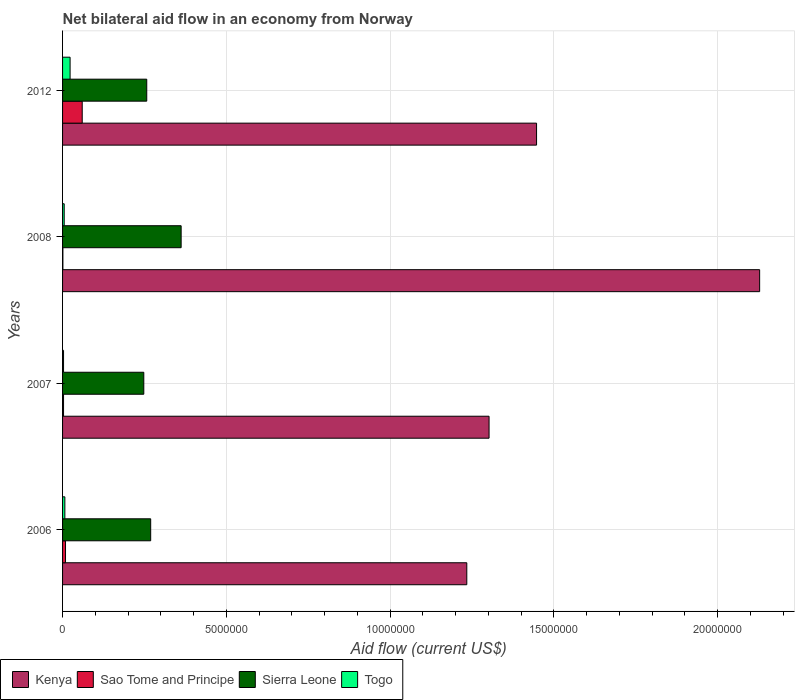How many different coloured bars are there?
Your response must be concise. 4. Are the number of bars on each tick of the Y-axis equal?
Your response must be concise. Yes. How many bars are there on the 2nd tick from the bottom?
Offer a terse response. 4. In how many cases, is the number of bars for a given year not equal to the number of legend labels?
Give a very brief answer. 0. What is the net bilateral aid flow in Sierra Leone in 2012?
Make the answer very short. 2.57e+06. Across all years, what is the minimum net bilateral aid flow in Kenya?
Your answer should be compact. 1.23e+07. In which year was the net bilateral aid flow in Sao Tome and Principe maximum?
Provide a short and direct response. 2012. In which year was the net bilateral aid flow in Sierra Leone minimum?
Your answer should be very brief. 2007. What is the total net bilateral aid flow in Kenya in the graph?
Ensure brevity in your answer.  6.11e+07. What is the difference between the net bilateral aid flow in Sao Tome and Principe in 2007 and the net bilateral aid flow in Kenya in 2012?
Your response must be concise. -1.44e+07. What is the average net bilateral aid flow in Sierra Leone per year?
Give a very brief answer. 2.84e+06. In the year 2007, what is the difference between the net bilateral aid flow in Sierra Leone and net bilateral aid flow in Togo?
Your answer should be very brief. 2.45e+06. What is the ratio of the net bilateral aid flow in Sierra Leone in 2006 to that in 2012?
Your response must be concise. 1.05. Is the net bilateral aid flow in Sierra Leone in 2008 less than that in 2012?
Make the answer very short. No. Is the difference between the net bilateral aid flow in Sierra Leone in 2006 and 2012 greater than the difference between the net bilateral aid flow in Togo in 2006 and 2012?
Your answer should be very brief. Yes. What is the difference between the highest and the second highest net bilateral aid flow in Togo?
Your answer should be very brief. 1.60e+05. What is the difference between the highest and the lowest net bilateral aid flow in Sao Tome and Principe?
Your answer should be compact. 5.90e+05. In how many years, is the net bilateral aid flow in Togo greater than the average net bilateral aid flow in Togo taken over all years?
Provide a succinct answer. 1. Is it the case that in every year, the sum of the net bilateral aid flow in Kenya and net bilateral aid flow in Togo is greater than the sum of net bilateral aid flow in Sao Tome and Principe and net bilateral aid flow in Sierra Leone?
Provide a succinct answer. Yes. What does the 3rd bar from the top in 2007 represents?
Your answer should be very brief. Sao Tome and Principe. What does the 2nd bar from the bottom in 2007 represents?
Your answer should be compact. Sao Tome and Principe. Is it the case that in every year, the sum of the net bilateral aid flow in Sao Tome and Principe and net bilateral aid flow in Kenya is greater than the net bilateral aid flow in Togo?
Offer a very short reply. Yes. How many bars are there?
Provide a succinct answer. 16. Are all the bars in the graph horizontal?
Ensure brevity in your answer.  Yes. How many years are there in the graph?
Offer a terse response. 4. What is the difference between two consecutive major ticks on the X-axis?
Offer a very short reply. 5.00e+06. Does the graph contain grids?
Your response must be concise. Yes. Where does the legend appear in the graph?
Provide a succinct answer. Bottom left. How many legend labels are there?
Ensure brevity in your answer.  4. What is the title of the graph?
Offer a very short reply. Net bilateral aid flow in an economy from Norway. What is the Aid flow (current US$) of Kenya in 2006?
Your response must be concise. 1.23e+07. What is the Aid flow (current US$) of Sao Tome and Principe in 2006?
Your response must be concise. 9.00e+04. What is the Aid flow (current US$) in Sierra Leone in 2006?
Your response must be concise. 2.69e+06. What is the Aid flow (current US$) in Kenya in 2007?
Make the answer very short. 1.30e+07. What is the Aid flow (current US$) in Sao Tome and Principe in 2007?
Provide a succinct answer. 3.00e+04. What is the Aid flow (current US$) in Sierra Leone in 2007?
Make the answer very short. 2.48e+06. What is the Aid flow (current US$) in Kenya in 2008?
Ensure brevity in your answer.  2.13e+07. What is the Aid flow (current US$) of Sao Tome and Principe in 2008?
Give a very brief answer. 10000. What is the Aid flow (current US$) of Sierra Leone in 2008?
Keep it short and to the point. 3.62e+06. What is the Aid flow (current US$) in Togo in 2008?
Offer a terse response. 5.00e+04. What is the Aid flow (current US$) in Kenya in 2012?
Your response must be concise. 1.45e+07. What is the Aid flow (current US$) in Sierra Leone in 2012?
Give a very brief answer. 2.57e+06. What is the Aid flow (current US$) in Togo in 2012?
Your answer should be compact. 2.30e+05. Across all years, what is the maximum Aid flow (current US$) of Kenya?
Give a very brief answer. 2.13e+07. Across all years, what is the maximum Aid flow (current US$) of Sao Tome and Principe?
Provide a short and direct response. 6.00e+05. Across all years, what is the maximum Aid flow (current US$) in Sierra Leone?
Make the answer very short. 3.62e+06. Across all years, what is the minimum Aid flow (current US$) in Kenya?
Provide a short and direct response. 1.23e+07. Across all years, what is the minimum Aid flow (current US$) of Sao Tome and Principe?
Your response must be concise. 10000. Across all years, what is the minimum Aid flow (current US$) of Sierra Leone?
Make the answer very short. 2.48e+06. What is the total Aid flow (current US$) in Kenya in the graph?
Provide a short and direct response. 6.11e+07. What is the total Aid flow (current US$) of Sao Tome and Principe in the graph?
Keep it short and to the point. 7.30e+05. What is the total Aid flow (current US$) in Sierra Leone in the graph?
Make the answer very short. 1.14e+07. What is the total Aid flow (current US$) in Togo in the graph?
Keep it short and to the point. 3.80e+05. What is the difference between the Aid flow (current US$) of Kenya in 2006 and that in 2007?
Offer a very short reply. -6.80e+05. What is the difference between the Aid flow (current US$) of Sierra Leone in 2006 and that in 2007?
Your answer should be very brief. 2.10e+05. What is the difference between the Aid flow (current US$) of Togo in 2006 and that in 2007?
Provide a succinct answer. 4.00e+04. What is the difference between the Aid flow (current US$) in Kenya in 2006 and that in 2008?
Your answer should be compact. -8.94e+06. What is the difference between the Aid flow (current US$) in Sao Tome and Principe in 2006 and that in 2008?
Give a very brief answer. 8.00e+04. What is the difference between the Aid flow (current US$) of Sierra Leone in 2006 and that in 2008?
Make the answer very short. -9.30e+05. What is the difference between the Aid flow (current US$) of Kenya in 2006 and that in 2012?
Your answer should be very brief. -2.13e+06. What is the difference between the Aid flow (current US$) in Sao Tome and Principe in 2006 and that in 2012?
Give a very brief answer. -5.10e+05. What is the difference between the Aid flow (current US$) of Togo in 2006 and that in 2012?
Your answer should be very brief. -1.60e+05. What is the difference between the Aid flow (current US$) in Kenya in 2007 and that in 2008?
Ensure brevity in your answer.  -8.26e+06. What is the difference between the Aid flow (current US$) of Sierra Leone in 2007 and that in 2008?
Your answer should be very brief. -1.14e+06. What is the difference between the Aid flow (current US$) of Kenya in 2007 and that in 2012?
Ensure brevity in your answer.  -1.45e+06. What is the difference between the Aid flow (current US$) in Sao Tome and Principe in 2007 and that in 2012?
Provide a short and direct response. -5.70e+05. What is the difference between the Aid flow (current US$) in Sierra Leone in 2007 and that in 2012?
Offer a terse response. -9.00e+04. What is the difference between the Aid flow (current US$) of Kenya in 2008 and that in 2012?
Ensure brevity in your answer.  6.81e+06. What is the difference between the Aid flow (current US$) of Sao Tome and Principe in 2008 and that in 2012?
Your response must be concise. -5.90e+05. What is the difference between the Aid flow (current US$) of Sierra Leone in 2008 and that in 2012?
Give a very brief answer. 1.05e+06. What is the difference between the Aid flow (current US$) in Kenya in 2006 and the Aid flow (current US$) in Sao Tome and Principe in 2007?
Your response must be concise. 1.23e+07. What is the difference between the Aid flow (current US$) of Kenya in 2006 and the Aid flow (current US$) of Sierra Leone in 2007?
Give a very brief answer. 9.86e+06. What is the difference between the Aid flow (current US$) in Kenya in 2006 and the Aid flow (current US$) in Togo in 2007?
Your answer should be very brief. 1.23e+07. What is the difference between the Aid flow (current US$) of Sao Tome and Principe in 2006 and the Aid flow (current US$) of Sierra Leone in 2007?
Give a very brief answer. -2.39e+06. What is the difference between the Aid flow (current US$) in Sao Tome and Principe in 2006 and the Aid flow (current US$) in Togo in 2007?
Provide a short and direct response. 6.00e+04. What is the difference between the Aid flow (current US$) of Sierra Leone in 2006 and the Aid flow (current US$) of Togo in 2007?
Keep it short and to the point. 2.66e+06. What is the difference between the Aid flow (current US$) of Kenya in 2006 and the Aid flow (current US$) of Sao Tome and Principe in 2008?
Provide a succinct answer. 1.23e+07. What is the difference between the Aid flow (current US$) in Kenya in 2006 and the Aid flow (current US$) in Sierra Leone in 2008?
Keep it short and to the point. 8.72e+06. What is the difference between the Aid flow (current US$) of Kenya in 2006 and the Aid flow (current US$) of Togo in 2008?
Offer a very short reply. 1.23e+07. What is the difference between the Aid flow (current US$) in Sao Tome and Principe in 2006 and the Aid flow (current US$) in Sierra Leone in 2008?
Offer a terse response. -3.53e+06. What is the difference between the Aid flow (current US$) of Sao Tome and Principe in 2006 and the Aid flow (current US$) of Togo in 2008?
Offer a very short reply. 4.00e+04. What is the difference between the Aid flow (current US$) of Sierra Leone in 2006 and the Aid flow (current US$) of Togo in 2008?
Your response must be concise. 2.64e+06. What is the difference between the Aid flow (current US$) of Kenya in 2006 and the Aid flow (current US$) of Sao Tome and Principe in 2012?
Offer a very short reply. 1.17e+07. What is the difference between the Aid flow (current US$) of Kenya in 2006 and the Aid flow (current US$) of Sierra Leone in 2012?
Offer a very short reply. 9.77e+06. What is the difference between the Aid flow (current US$) in Kenya in 2006 and the Aid flow (current US$) in Togo in 2012?
Your answer should be very brief. 1.21e+07. What is the difference between the Aid flow (current US$) in Sao Tome and Principe in 2006 and the Aid flow (current US$) in Sierra Leone in 2012?
Your answer should be very brief. -2.48e+06. What is the difference between the Aid flow (current US$) in Sierra Leone in 2006 and the Aid flow (current US$) in Togo in 2012?
Your response must be concise. 2.46e+06. What is the difference between the Aid flow (current US$) of Kenya in 2007 and the Aid flow (current US$) of Sao Tome and Principe in 2008?
Offer a very short reply. 1.30e+07. What is the difference between the Aid flow (current US$) in Kenya in 2007 and the Aid flow (current US$) in Sierra Leone in 2008?
Offer a very short reply. 9.40e+06. What is the difference between the Aid flow (current US$) of Kenya in 2007 and the Aid flow (current US$) of Togo in 2008?
Keep it short and to the point. 1.30e+07. What is the difference between the Aid flow (current US$) of Sao Tome and Principe in 2007 and the Aid flow (current US$) of Sierra Leone in 2008?
Make the answer very short. -3.59e+06. What is the difference between the Aid flow (current US$) of Sierra Leone in 2007 and the Aid flow (current US$) of Togo in 2008?
Ensure brevity in your answer.  2.43e+06. What is the difference between the Aid flow (current US$) of Kenya in 2007 and the Aid flow (current US$) of Sao Tome and Principe in 2012?
Provide a short and direct response. 1.24e+07. What is the difference between the Aid flow (current US$) of Kenya in 2007 and the Aid flow (current US$) of Sierra Leone in 2012?
Offer a very short reply. 1.04e+07. What is the difference between the Aid flow (current US$) of Kenya in 2007 and the Aid flow (current US$) of Togo in 2012?
Your response must be concise. 1.28e+07. What is the difference between the Aid flow (current US$) of Sao Tome and Principe in 2007 and the Aid flow (current US$) of Sierra Leone in 2012?
Make the answer very short. -2.54e+06. What is the difference between the Aid flow (current US$) of Sao Tome and Principe in 2007 and the Aid flow (current US$) of Togo in 2012?
Keep it short and to the point. -2.00e+05. What is the difference between the Aid flow (current US$) in Sierra Leone in 2007 and the Aid flow (current US$) in Togo in 2012?
Provide a succinct answer. 2.25e+06. What is the difference between the Aid flow (current US$) of Kenya in 2008 and the Aid flow (current US$) of Sao Tome and Principe in 2012?
Your answer should be compact. 2.07e+07. What is the difference between the Aid flow (current US$) of Kenya in 2008 and the Aid flow (current US$) of Sierra Leone in 2012?
Your answer should be very brief. 1.87e+07. What is the difference between the Aid flow (current US$) in Kenya in 2008 and the Aid flow (current US$) in Togo in 2012?
Ensure brevity in your answer.  2.10e+07. What is the difference between the Aid flow (current US$) in Sao Tome and Principe in 2008 and the Aid flow (current US$) in Sierra Leone in 2012?
Keep it short and to the point. -2.56e+06. What is the difference between the Aid flow (current US$) in Sao Tome and Principe in 2008 and the Aid flow (current US$) in Togo in 2012?
Your answer should be compact. -2.20e+05. What is the difference between the Aid flow (current US$) of Sierra Leone in 2008 and the Aid flow (current US$) of Togo in 2012?
Make the answer very short. 3.39e+06. What is the average Aid flow (current US$) in Kenya per year?
Offer a very short reply. 1.53e+07. What is the average Aid flow (current US$) of Sao Tome and Principe per year?
Provide a succinct answer. 1.82e+05. What is the average Aid flow (current US$) in Sierra Leone per year?
Ensure brevity in your answer.  2.84e+06. What is the average Aid flow (current US$) of Togo per year?
Give a very brief answer. 9.50e+04. In the year 2006, what is the difference between the Aid flow (current US$) of Kenya and Aid flow (current US$) of Sao Tome and Principe?
Give a very brief answer. 1.22e+07. In the year 2006, what is the difference between the Aid flow (current US$) in Kenya and Aid flow (current US$) in Sierra Leone?
Give a very brief answer. 9.65e+06. In the year 2006, what is the difference between the Aid flow (current US$) of Kenya and Aid flow (current US$) of Togo?
Keep it short and to the point. 1.23e+07. In the year 2006, what is the difference between the Aid flow (current US$) of Sao Tome and Principe and Aid flow (current US$) of Sierra Leone?
Give a very brief answer. -2.60e+06. In the year 2006, what is the difference between the Aid flow (current US$) of Sierra Leone and Aid flow (current US$) of Togo?
Ensure brevity in your answer.  2.62e+06. In the year 2007, what is the difference between the Aid flow (current US$) of Kenya and Aid flow (current US$) of Sao Tome and Principe?
Your response must be concise. 1.30e+07. In the year 2007, what is the difference between the Aid flow (current US$) in Kenya and Aid flow (current US$) in Sierra Leone?
Offer a terse response. 1.05e+07. In the year 2007, what is the difference between the Aid flow (current US$) of Kenya and Aid flow (current US$) of Togo?
Give a very brief answer. 1.30e+07. In the year 2007, what is the difference between the Aid flow (current US$) in Sao Tome and Principe and Aid flow (current US$) in Sierra Leone?
Your answer should be compact. -2.45e+06. In the year 2007, what is the difference between the Aid flow (current US$) of Sierra Leone and Aid flow (current US$) of Togo?
Keep it short and to the point. 2.45e+06. In the year 2008, what is the difference between the Aid flow (current US$) in Kenya and Aid flow (current US$) in Sao Tome and Principe?
Your response must be concise. 2.13e+07. In the year 2008, what is the difference between the Aid flow (current US$) of Kenya and Aid flow (current US$) of Sierra Leone?
Your response must be concise. 1.77e+07. In the year 2008, what is the difference between the Aid flow (current US$) of Kenya and Aid flow (current US$) of Togo?
Your answer should be very brief. 2.12e+07. In the year 2008, what is the difference between the Aid flow (current US$) of Sao Tome and Principe and Aid flow (current US$) of Sierra Leone?
Keep it short and to the point. -3.61e+06. In the year 2008, what is the difference between the Aid flow (current US$) in Sierra Leone and Aid flow (current US$) in Togo?
Keep it short and to the point. 3.57e+06. In the year 2012, what is the difference between the Aid flow (current US$) of Kenya and Aid flow (current US$) of Sao Tome and Principe?
Provide a short and direct response. 1.39e+07. In the year 2012, what is the difference between the Aid flow (current US$) of Kenya and Aid flow (current US$) of Sierra Leone?
Make the answer very short. 1.19e+07. In the year 2012, what is the difference between the Aid flow (current US$) of Kenya and Aid flow (current US$) of Togo?
Give a very brief answer. 1.42e+07. In the year 2012, what is the difference between the Aid flow (current US$) of Sao Tome and Principe and Aid flow (current US$) of Sierra Leone?
Offer a very short reply. -1.97e+06. In the year 2012, what is the difference between the Aid flow (current US$) of Sao Tome and Principe and Aid flow (current US$) of Togo?
Offer a terse response. 3.70e+05. In the year 2012, what is the difference between the Aid flow (current US$) of Sierra Leone and Aid flow (current US$) of Togo?
Your answer should be very brief. 2.34e+06. What is the ratio of the Aid flow (current US$) in Kenya in 2006 to that in 2007?
Offer a very short reply. 0.95. What is the ratio of the Aid flow (current US$) of Sierra Leone in 2006 to that in 2007?
Ensure brevity in your answer.  1.08. What is the ratio of the Aid flow (current US$) of Togo in 2006 to that in 2007?
Keep it short and to the point. 2.33. What is the ratio of the Aid flow (current US$) of Kenya in 2006 to that in 2008?
Give a very brief answer. 0.58. What is the ratio of the Aid flow (current US$) in Sierra Leone in 2006 to that in 2008?
Give a very brief answer. 0.74. What is the ratio of the Aid flow (current US$) of Togo in 2006 to that in 2008?
Provide a short and direct response. 1.4. What is the ratio of the Aid flow (current US$) in Kenya in 2006 to that in 2012?
Give a very brief answer. 0.85. What is the ratio of the Aid flow (current US$) in Sao Tome and Principe in 2006 to that in 2012?
Offer a terse response. 0.15. What is the ratio of the Aid flow (current US$) of Sierra Leone in 2006 to that in 2012?
Make the answer very short. 1.05. What is the ratio of the Aid flow (current US$) in Togo in 2006 to that in 2012?
Your answer should be very brief. 0.3. What is the ratio of the Aid flow (current US$) in Kenya in 2007 to that in 2008?
Keep it short and to the point. 0.61. What is the ratio of the Aid flow (current US$) in Sierra Leone in 2007 to that in 2008?
Provide a short and direct response. 0.69. What is the ratio of the Aid flow (current US$) in Togo in 2007 to that in 2008?
Offer a terse response. 0.6. What is the ratio of the Aid flow (current US$) in Kenya in 2007 to that in 2012?
Make the answer very short. 0.9. What is the ratio of the Aid flow (current US$) in Sao Tome and Principe in 2007 to that in 2012?
Your answer should be very brief. 0.05. What is the ratio of the Aid flow (current US$) in Togo in 2007 to that in 2012?
Give a very brief answer. 0.13. What is the ratio of the Aid flow (current US$) of Kenya in 2008 to that in 2012?
Your response must be concise. 1.47. What is the ratio of the Aid flow (current US$) in Sao Tome and Principe in 2008 to that in 2012?
Your response must be concise. 0.02. What is the ratio of the Aid flow (current US$) in Sierra Leone in 2008 to that in 2012?
Your answer should be very brief. 1.41. What is the ratio of the Aid flow (current US$) of Togo in 2008 to that in 2012?
Your answer should be compact. 0.22. What is the difference between the highest and the second highest Aid flow (current US$) in Kenya?
Your answer should be very brief. 6.81e+06. What is the difference between the highest and the second highest Aid flow (current US$) of Sao Tome and Principe?
Make the answer very short. 5.10e+05. What is the difference between the highest and the second highest Aid flow (current US$) in Sierra Leone?
Offer a very short reply. 9.30e+05. What is the difference between the highest and the second highest Aid flow (current US$) of Togo?
Your response must be concise. 1.60e+05. What is the difference between the highest and the lowest Aid flow (current US$) in Kenya?
Your response must be concise. 8.94e+06. What is the difference between the highest and the lowest Aid flow (current US$) in Sao Tome and Principe?
Offer a terse response. 5.90e+05. What is the difference between the highest and the lowest Aid flow (current US$) in Sierra Leone?
Offer a terse response. 1.14e+06. 